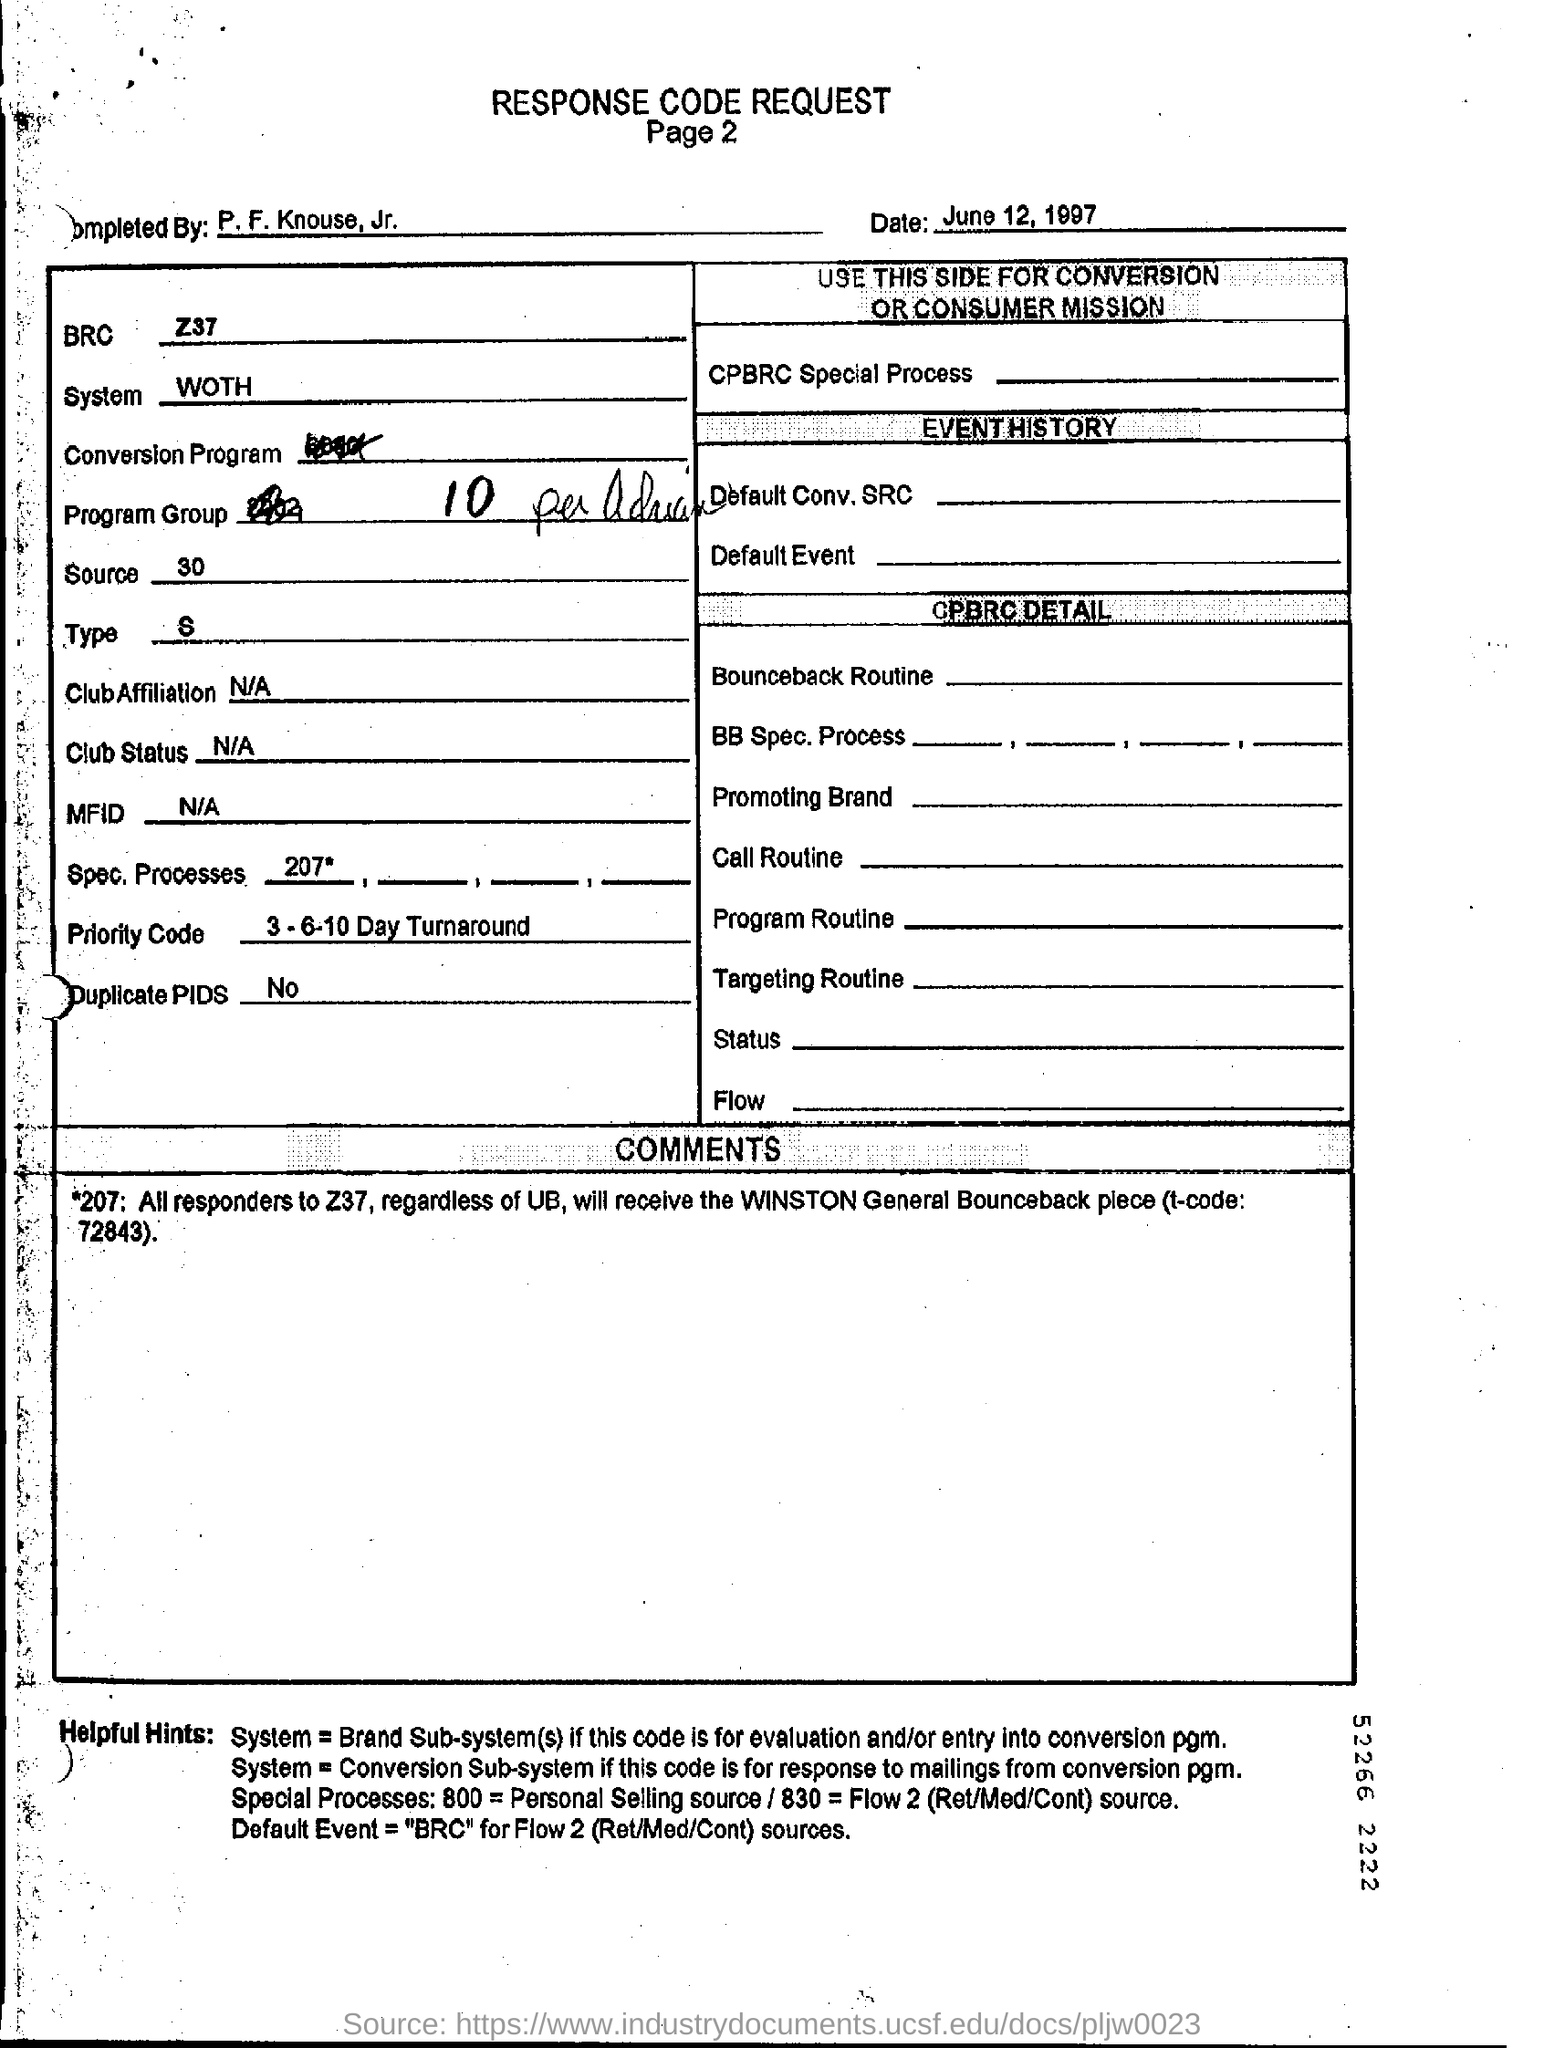Identify some key points in this picture. The Priority Code is a 3-6-10 day turnaround service that ensures prompt delivery of urgent documents. The date mentioned in the form is June 12, 1997. The table provided does not show any duplicate Process ID (PID) values. 